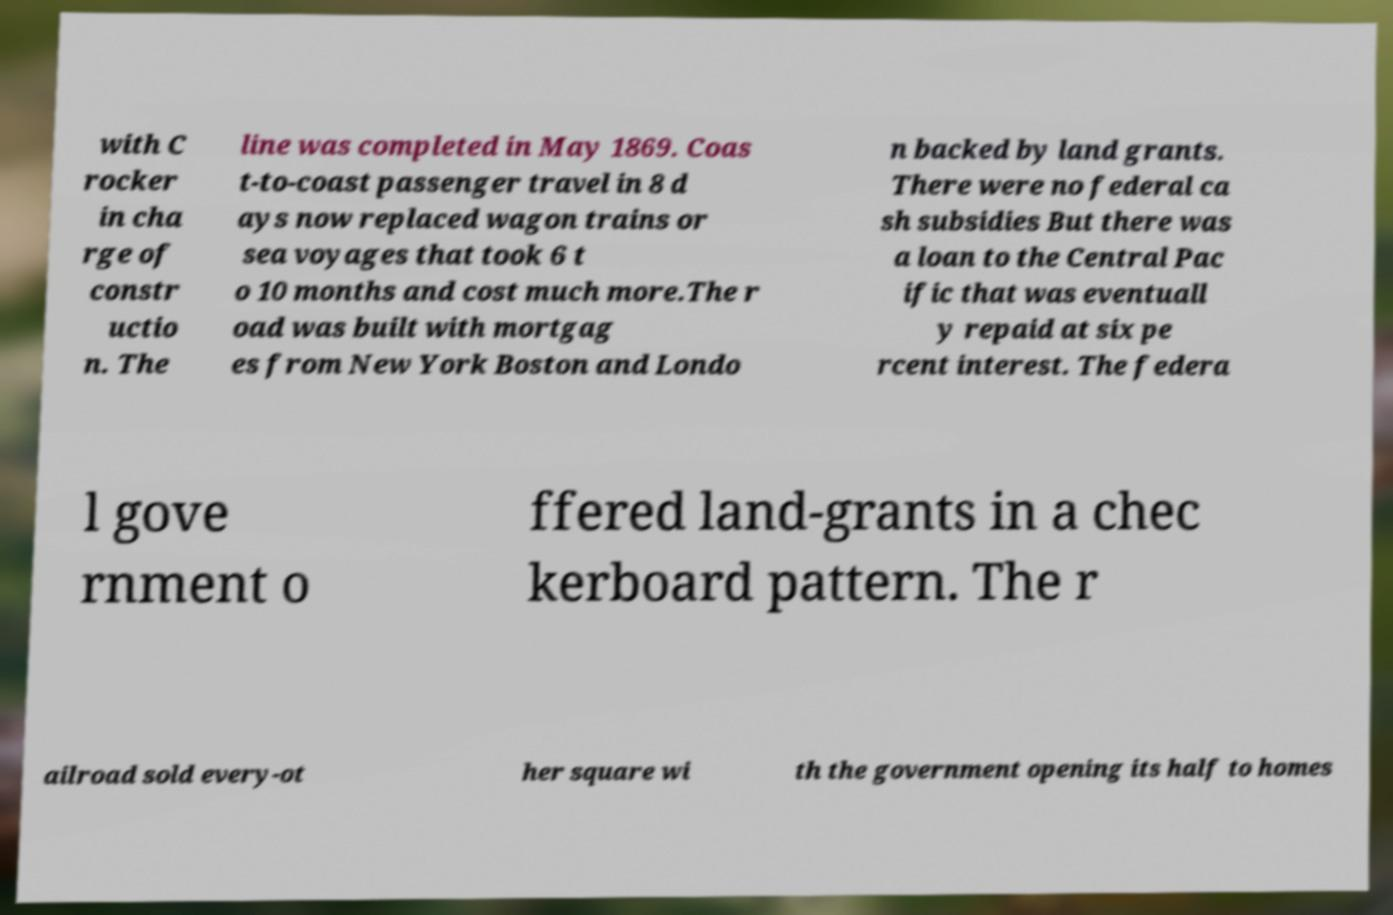Could you assist in decoding the text presented in this image and type it out clearly? with C rocker in cha rge of constr uctio n. The line was completed in May 1869. Coas t-to-coast passenger travel in 8 d ays now replaced wagon trains or sea voyages that took 6 t o 10 months and cost much more.The r oad was built with mortgag es from New York Boston and Londo n backed by land grants. There were no federal ca sh subsidies But there was a loan to the Central Pac ific that was eventuall y repaid at six pe rcent interest. The federa l gove rnment o ffered land-grants in a chec kerboard pattern. The r ailroad sold every-ot her square wi th the government opening its half to homes 